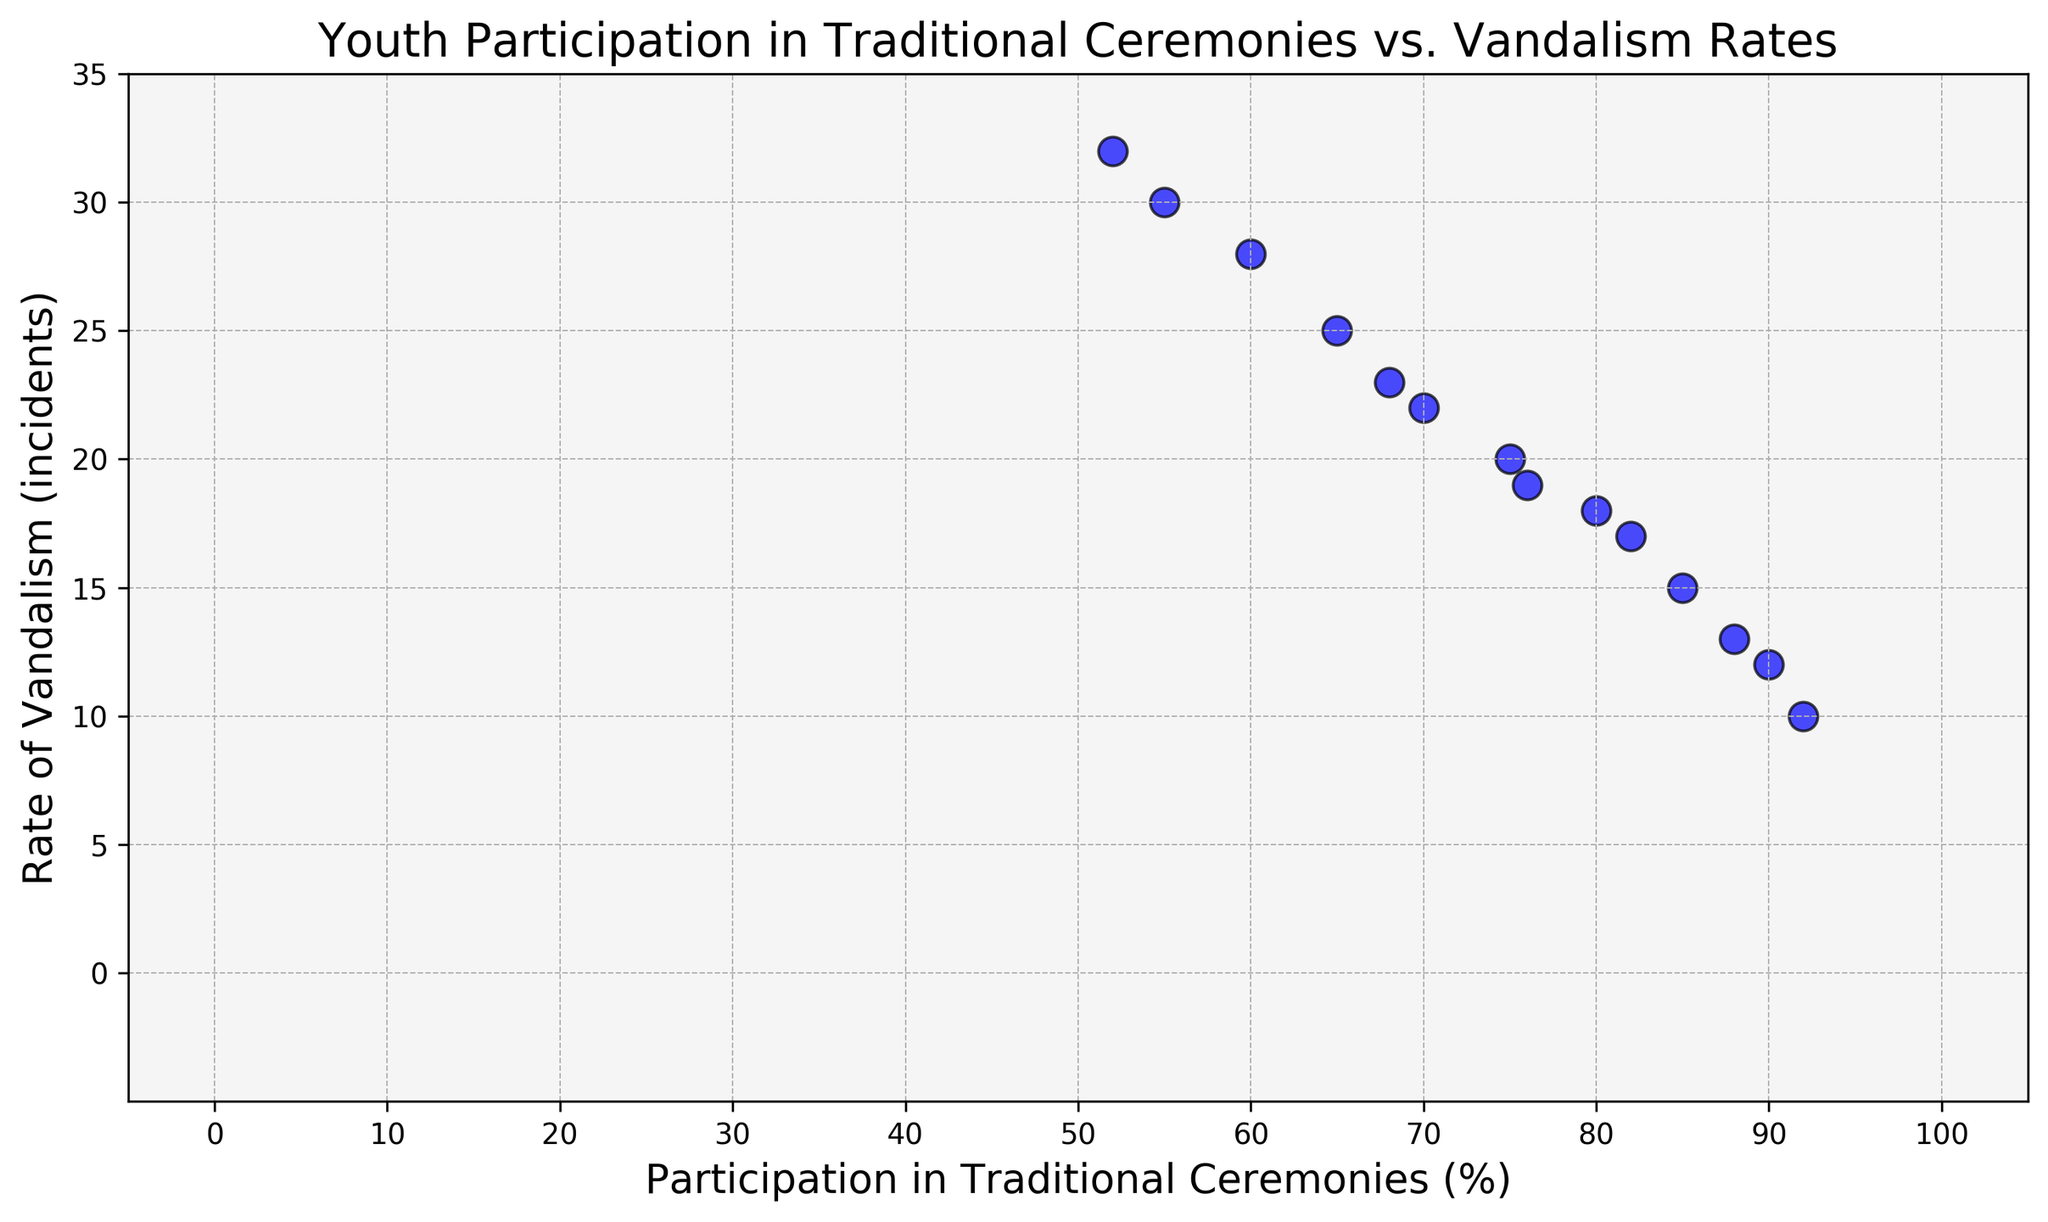Is there a trend between participation in traditional ceremonies and vandalism rates? Examine the overall direction of scatter points. Higher participation rates are associated with lower vandalism incidents, indicating a negative correlation.
Answer: Negative correlation What is the rate of vandalism when participation in traditional ceremonies is 70%? Find the point corresponding to 70% on the x-axis and trace it to its y-axis value.
Answer: 22 Which year had the highest participation in traditional ceremonies? Look for the maximum x-axis value and check the corresponding year.
Answer: 2023 How does the vandalism rate in 2013 compare to 2023? Locate both years on the x-axis. 2013 has a vandalism rate of 25, and 2023 has 10. Compare these values.
Answer: Lower in 2023 What is the difference in participation in traditional ceremonies between 2010 and 2019? Subtract the participation rate in 2010 (55%) from the rate in 2019 (90%).
Answer: 35% What is the collective change in vandalism rates from 2010 to 2023? Subtract the rate in 2010 (30 incidents) from the rate in 2023 (10 incidents).
Answer: 20 incidents During which year did the participation rate in traditional ceremonies peak? Identify the highest x-axis value and note the corresponding year.
Answer: 2023 What is the overall trend in vandalism rates from 2010 to 2023? Observe the pattern of y-axis values over time. They decrease progressively as the participation increases.
Answer: Downward trend How does the rate of vandalism in 2018 compare to the rate in 2016? Find both years on the x-axis, compare their y-values. 2018 has 15 incidents, and 2016 has 23 incidents.
Answer: Lower in 2018 At what level of participation is the vandalism rate lowest, and what is that rate? Identify the minimum y-axis value. The lowest vandalism rate (10 incidents) occurs at 92% participation.
Answer: 92%, 10 